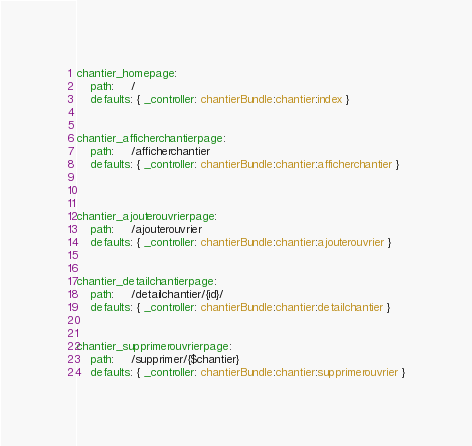Convert code to text. <code><loc_0><loc_0><loc_500><loc_500><_YAML_>chantier_homepage:
    path:     /
    defaults: { _controller: chantierBundle:chantier:index }


chantier_afficherchantierpage:
    path:     /afficherchantier
    defaults: { _controller: chantierBundle:chantier:afficherchantier }
    
    
    
chantier_ajouterouvrierpage:
    path:     /ajouterouvrier
    defaults: { _controller: chantierBundle:chantier:ajouterouvrier }
    
    
chantier_detailchantierpage:
    path:     /detailchantier/{id}/
    defaults: { _controller: chantierBundle:chantier:detailchantier }
    
    
chantier_supprimerouvrierpage:
    path:     /supprimer/{$chantier}
    defaults: { _controller: chantierBundle:chantier:supprimerouvrier }</code> 